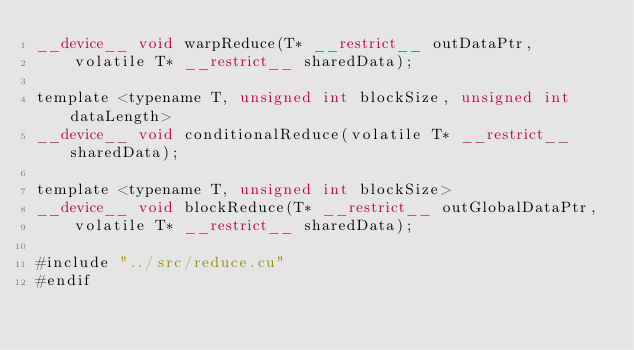Convert code to text. <code><loc_0><loc_0><loc_500><loc_500><_Cuda_>__device__ void warpReduce(T* __restrict__ outDataPtr,
    volatile T* __restrict__ sharedData);

template <typename T, unsigned int blockSize, unsigned int dataLength>
__device__ void conditionalReduce(volatile T* __restrict__ sharedData);

template <typename T, unsigned int blockSize>
__device__ void blockReduce(T* __restrict__ outGlobalDataPtr,
    volatile T* __restrict__ sharedData);

#include "../src/reduce.cu"
#endif
</code> 